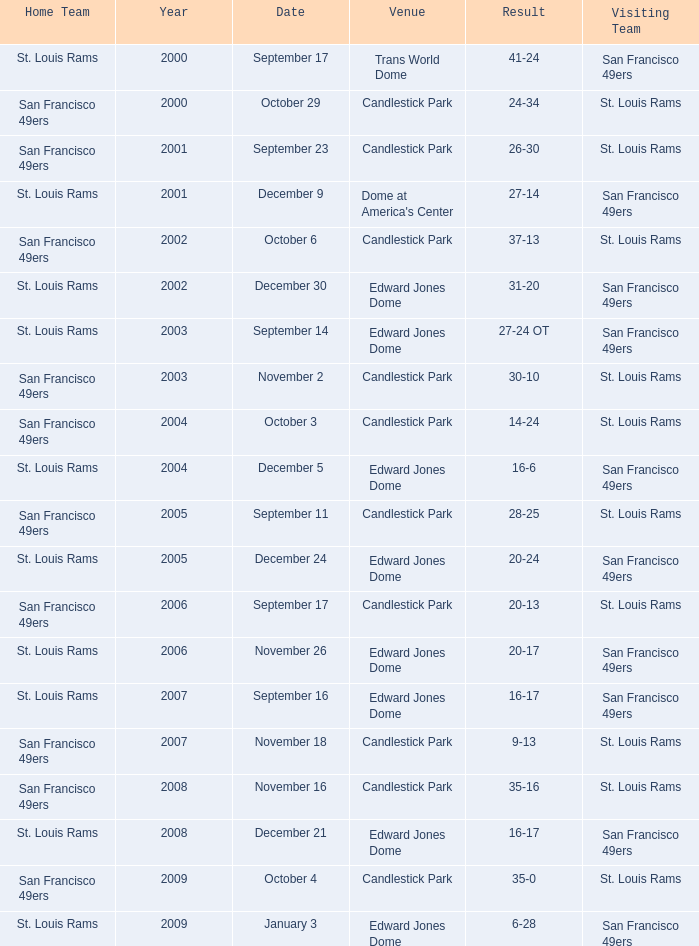Help me parse the entirety of this table. {'header': ['Home Team', 'Year', 'Date', 'Venue', 'Result', 'Visiting Team'], 'rows': [['St. Louis Rams', '2000', 'September 17', 'Trans World Dome', '41-24', 'San Francisco 49ers'], ['San Francisco 49ers', '2000', 'October 29', 'Candlestick Park', '24-34', 'St. Louis Rams'], ['San Francisco 49ers', '2001', 'September 23', 'Candlestick Park', '26-30', 'St. Louis Rams'], ['St. Louis Rams', '2001', 'December 9', "Dome at America's Center", '27-14', 'San Francisco 49ers'], ['San Francisco 49ers', '2002', 'October 6', 'Candlestick Park', '37-13', 'St. Louis Rams'], ['St. Louis Rams', '2002', 'December 30', 'Edward Jones Dome', '31-20', 'San Francisco 49ers'], ['St. Louis Rams', '2003', 'September 14', 'Edward Jones Dome', '27-24 OT', 'San Francisco 49ers'], ['San Francisco 49ers', '2003', 'November 2', 'Candlestick Park', '30-10', 'St. Louis Rams'], ['San Francisco 49ers', '2004', 'October 3', 'Candlestick Park', '14-24', 'St. Louis Rams'], ['St. Louis Rams', '2004', 'December 5', 'Edward Jones Dome', '16-6', 'San Francisco 49ers'], ['San Francisco 49ers', '2005', 'September 11', 'Candlestick Park', '28-25', 'St. Louis Rams'], ['St. Louis Rams', '2005', 'December 24', 'Edward Jones Dome', '20-24', 'San Francisco 49ers'], ['San Francisco 49ers', '2006', 'September 17', 'Candlestick Park', '20-13', 'St. Louis Rams'], ['St. Louis Rams', '2006', 'November 26', 'Edward Jones Dome', '20-17', 'San Francisco 49ers'], ['St. Louis Rams', '2007', 'September 16', 'Edward Jones Dome', '16-17', 'San Francisco 49ers'], ['San Francisco 49ers', '2007', 'November 18', 'Candlestick Park', '9-13', 'St. Louis Rams'], ['San Francisco 49ers', '2008', 'November 16', 'Candlestick Park', '35-16', 'St. Louis Rams'], ['St. Louis Rams', '2008', 'December 21', 'Edward Jones Dome', '16-17', 'San Francisco 49ers'], ['San Francisco 49ers', '2009', 'October 4', 'Candlestick Park', '35-0', 'St. Louis Rams'], ['St. Louis Rams', '2009', 'January 3', 'Edward Jones Dome', '6-28', 'San Francisco 49ers']]} What is the Result of the game on October 3? 14-24. 